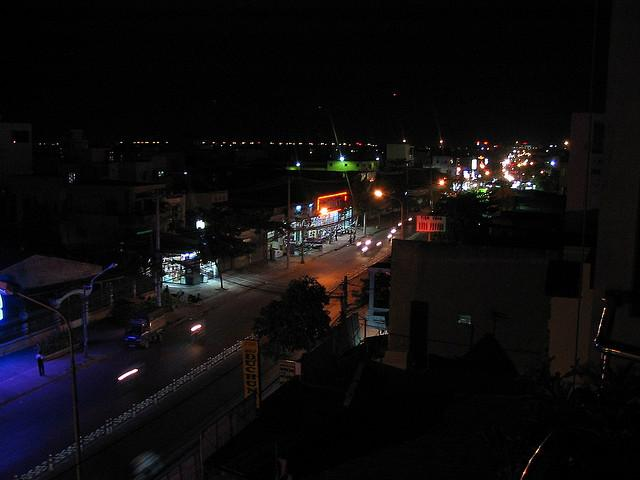What are is the image from?

Choices:
A) sky
B) city
C) underground
D) forest city 